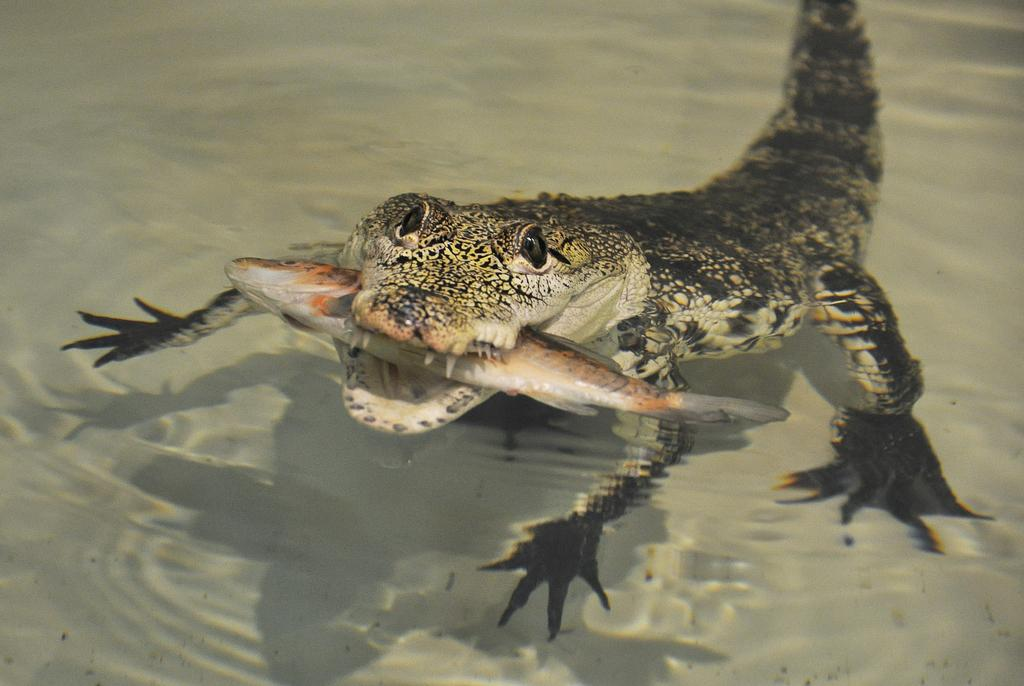What type of animal can be seen in the image? There is a water animal in the image. What is the water animal doing with its mouth? The water animal is holding a fish in its mouth. Where are the water animal and the fish located? The water animal and the fish are in the water. Can you tell me how much cheese the water animal is carrying in the image? There is no cheese present in the image; the water animal is holding a fish in its mouth. 